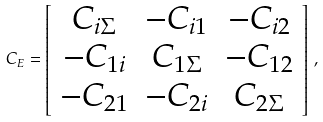<formula> <loc_0><loc_0><loc_500><loc_500>C _ { E } = \left [ \begin{array} { c c c } C _ { i \Sigma } & - C _ { i 1 } & - C _ { i 2 } \\ - C _ { 1 i } & C _ { 1 \Sigma } & - C _ { 1 2 } \\ - C _ { 2 1 } & - C _ { 2 i } & C _ { 2 \Sigma } \end{array} \right ] \, ,</formula> 